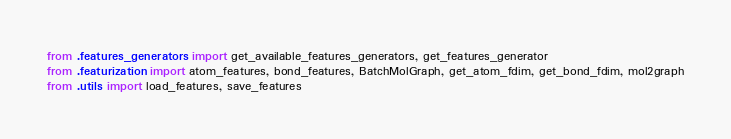Convert code to text. <code><loc_0><loc_0><loc_500><loc_500><_Python_>from .features_generators import get_available_features_generators, get_features_generator
from .featurization import atom_features, bond_features, BatchMolGraph, get_atom_fdim, get_bond_fdim, mol2graph
from .utils import load_features, save_features
</code> 